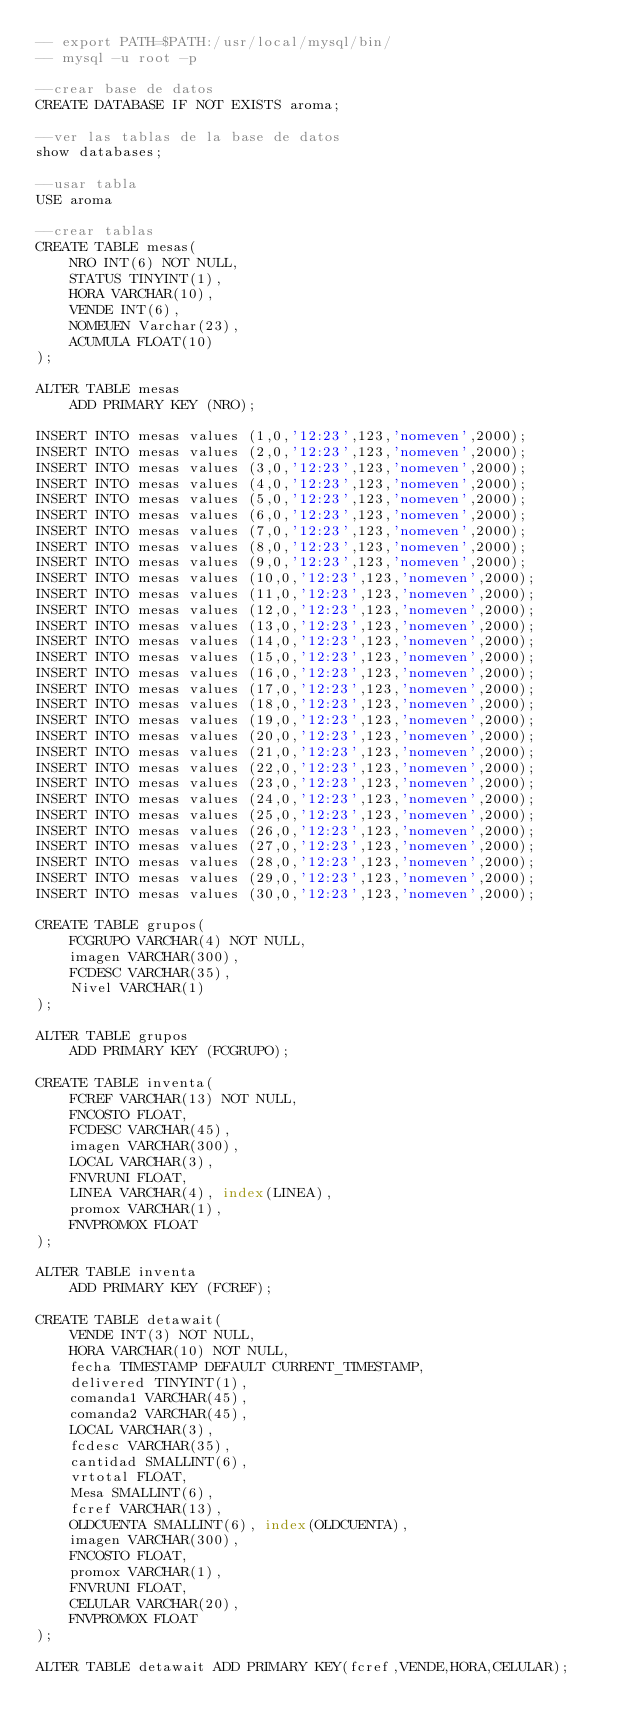Convert code to text. <code><loc_0><loc_0><loc_500><loc_500><_SQL_>-- export PATH=$PATH:/usr/local/mysql/bin/
-- mysql -u root -p

--crear base de datos
CREATE DATABASE IF NOT EXISTS aroma;

--ver las tablas de la base de datos
show databases;

--usar tabla
USE aroma

--crear tablas
CREATE TABLE mesas(
    NRO INT(6) NOT NULL,
    STATUS TINYINT(1),
    HORA VARCHAR(10),
    VENDE INT(6),
    NOMEUEN Varchar(23),
    ACUMULA FLOAT(10)
);

ALTER TABLE mesas
    ADD PRIMARY KEY (NRO);

INSERT INTO mesas values (1,0,'12:23',123,'nomeven',2000);
INSERT INTO mesas values (2,0,'12:23',123,'nomeven',2000);
INSERT INTO mesas values (3,0,'12:23',123,'nomeven',2000);
INSERT INTO mesas values (4,0,'12:23',123,'nomeven',2000);
INSERT INTO mesas values (5,0,'12:23',123,'nomeven',2000);
INSERT INTO mesas values (6,0,'12:23',123,'nomeven',2000);
INSERT INTO mesas values (7,0,'12:23',123,'nomeven',2000);
INSERT INTO mesas values (8,0,'12:23',123,'nomeven',2000);
INSERT INTO mesas values (9,0,'12:23',123,'nomeven',2000);
INSERT INTO mesas values (10,0,'12:23',123,'nomeven',2000);
INSERT INTO mesas values (11,0,'12:23',123,'nomeven',2000);
INSERT INTO mesas values (12,0,'12:23',123,'nomeven',2000);
INSERT INTO mesas values (13,0,'12:23',123,'nomeven',2000);
INSERT INTO mesas values (14,0,'12:23',123,'nomeven',2000);
INSERT INTO mesas values (15,0,'12:23',123,'nomeven',2000);
INSERT INTO mesas values (16,0,'12:23',123,'nomeven',2000);
INSERT INTO mesas values (17,0,'12:23',123,'nomeven',2000);
INSERT INTO mesas values (18,0,'12:23',123,'nomeven',2000);
INSERT INTO mesas values (19,0,'12:23',123,'nomeven',2000);
INSERT INTO mesas values (20,0,'12:23',123,'nomeven',2000);
INSERT INTO mesas values (21,0,'12:23',123,'nomeven',2000);
INSERT INTO mesas values (22,0,'12:23',123,'nomeven',2000);
INSERT INTO mesas values (23,0,'12:23',123,'nomeven',2000);
INSERT INTO mesas values (24,0,'12:23',123,'nomeven',2000);
INSERT INTO mesas values (25,0,'12:23',123,'nomeven',2000);
INSERT INTO mesas values (26,0,'12:23',123,'nomeven',2000);
INSERT INTO mesas values (27,0,'12:23',123,'nomeven',2000);
INSERT INTO mesas values (28,0,'12:23',123,'nomeven',2000);
INSERT INTO mesas values (29,0,'12:23',123,'nomeven',2000);
INSERT INTO mesas values (30,0,'12:23',123,'nomeven',2000);

CREATE TABLE grupos(
    FCGRUPO VARCHAR(4) NOT NULL,
    imagen VARCHAR(300),
    FCDESC VARCHAR(35),
    Nivel VARCHAR(1)
);

ALTER TABLE grupos
    ADD PRIMARY KEY (FCGRUPO);

CREATE TABLE inventa(
    FCREF VARCHAR(13) NOT NULL,
    FNCOSTO FLOAT,
    FCDESC VARCHAR(45),
    imagen VARCHAR(300),
    LOCAL VARCHAR(3),
    FNVRUNI FLOAT,
    LINEA VARCHAR(4), index(LINEA),
    promox VARCHAR(1),
    FNVPROMOX FLOAT
);

ALTER TABLE inventa
    ADD PRIMARY KEY (FCREF);

CREATE TABLE detawait(
    VENDE INT(3) NOT NULL,
    HORA VARCHAR(10) NOT NULL,
    fecha TIMESTAMP DEFAULT CURRENT_TIMESTAMP,
    delivered TINYINT(1),
    comanda1 VARCHAR(45),
    comanda2 VARCHAR(45),
    LOCAL VARCHAR(3),
    fcdesc VARCHAR(35),
    cantidad SMALLINT(6),
    vrtotal FLOAT,
    Mesa SMALLINT(6),
    fcref VARCHAR(13),
    OLDCUENTA SMALLINT(6), index(OLDCUENTA),
    imagen VARCHAR(300),
    FNCOSTO FLOAT,
    promox VARCHAR(1),
    FNVRUNI FLOAT,
    CELULAR VARCHAR(20),
    FNVPROMOX FLOAT
);

ALTER TABLE detawait ADD PRIMARY KEY(fcref,VENDE,HORA,CELULAR);



</code> 